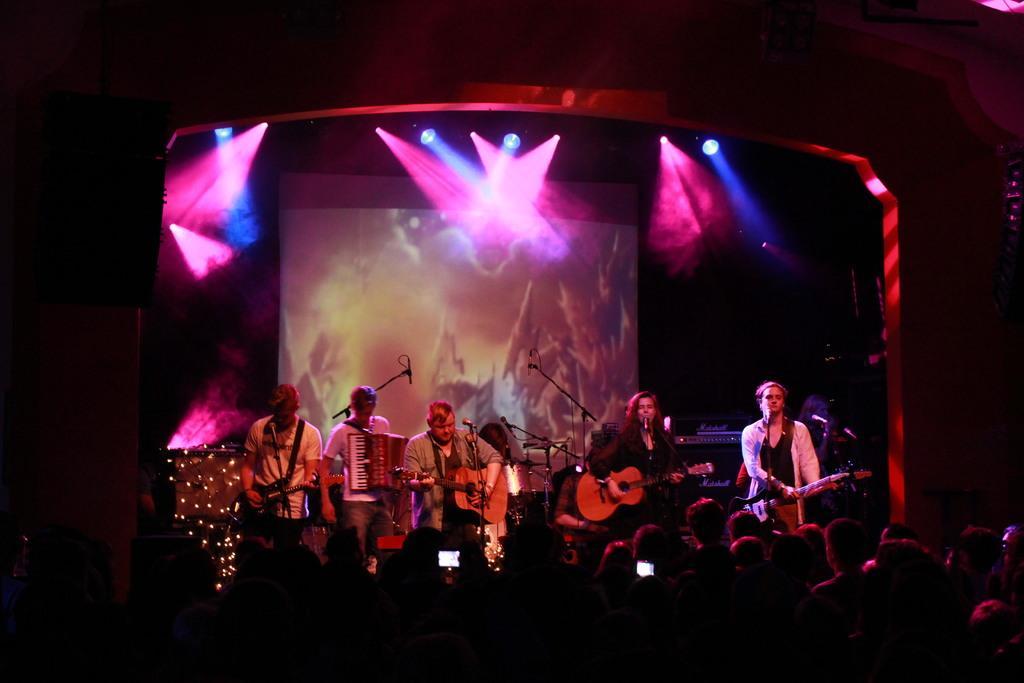How would you summarize this image in a sentence or two? In the foreground, I can see a crowd and a group of people are playing musical instruments on the stage. In the background, I can see a screen, focus lights and a dark color. This image is taken, maybe during night. 